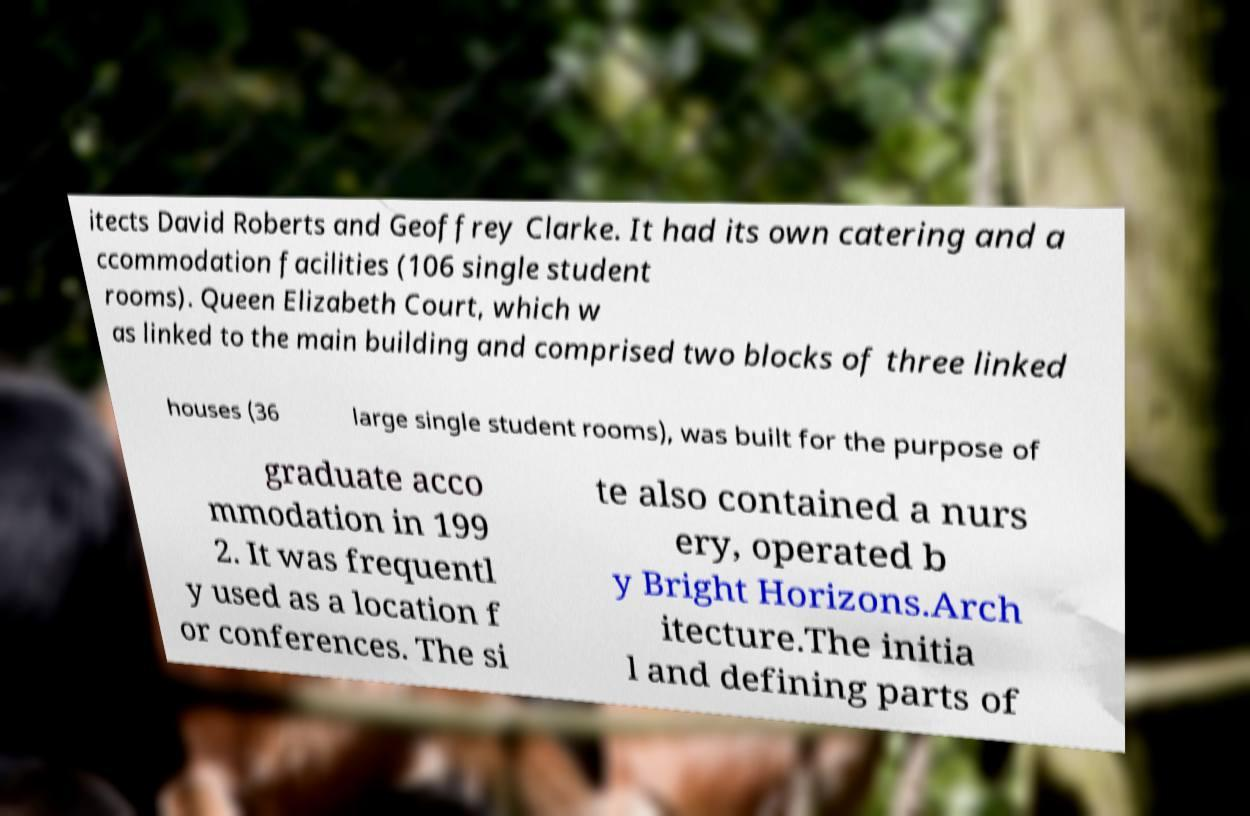For documentation purposes, I need the text within this image transcribed. Could you provide that? itects David Roberts and Geoffrey Clarke. It had its own catering and a ccommodation facilities (106 single student rooms). Queen Elizabeth Court, which w as linked to the main building and comprised two blocks of three linked houses (36 large single student rooms), was built for the purpose of graduate acco mmodation in 199 2. It was frequentl y used as a location f or conferences. The si te also contained a nurs ery, operated b y Bright Horizons.Arch itecture.The initia l and defining parts of 